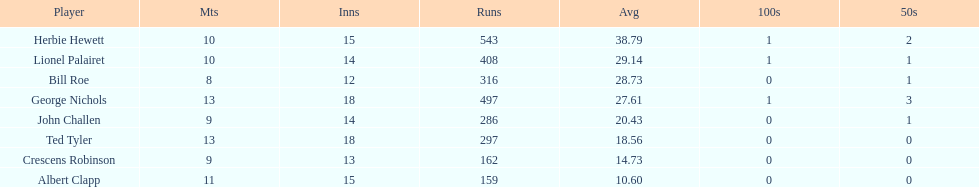What is the least about of runs anyone has? 159. 